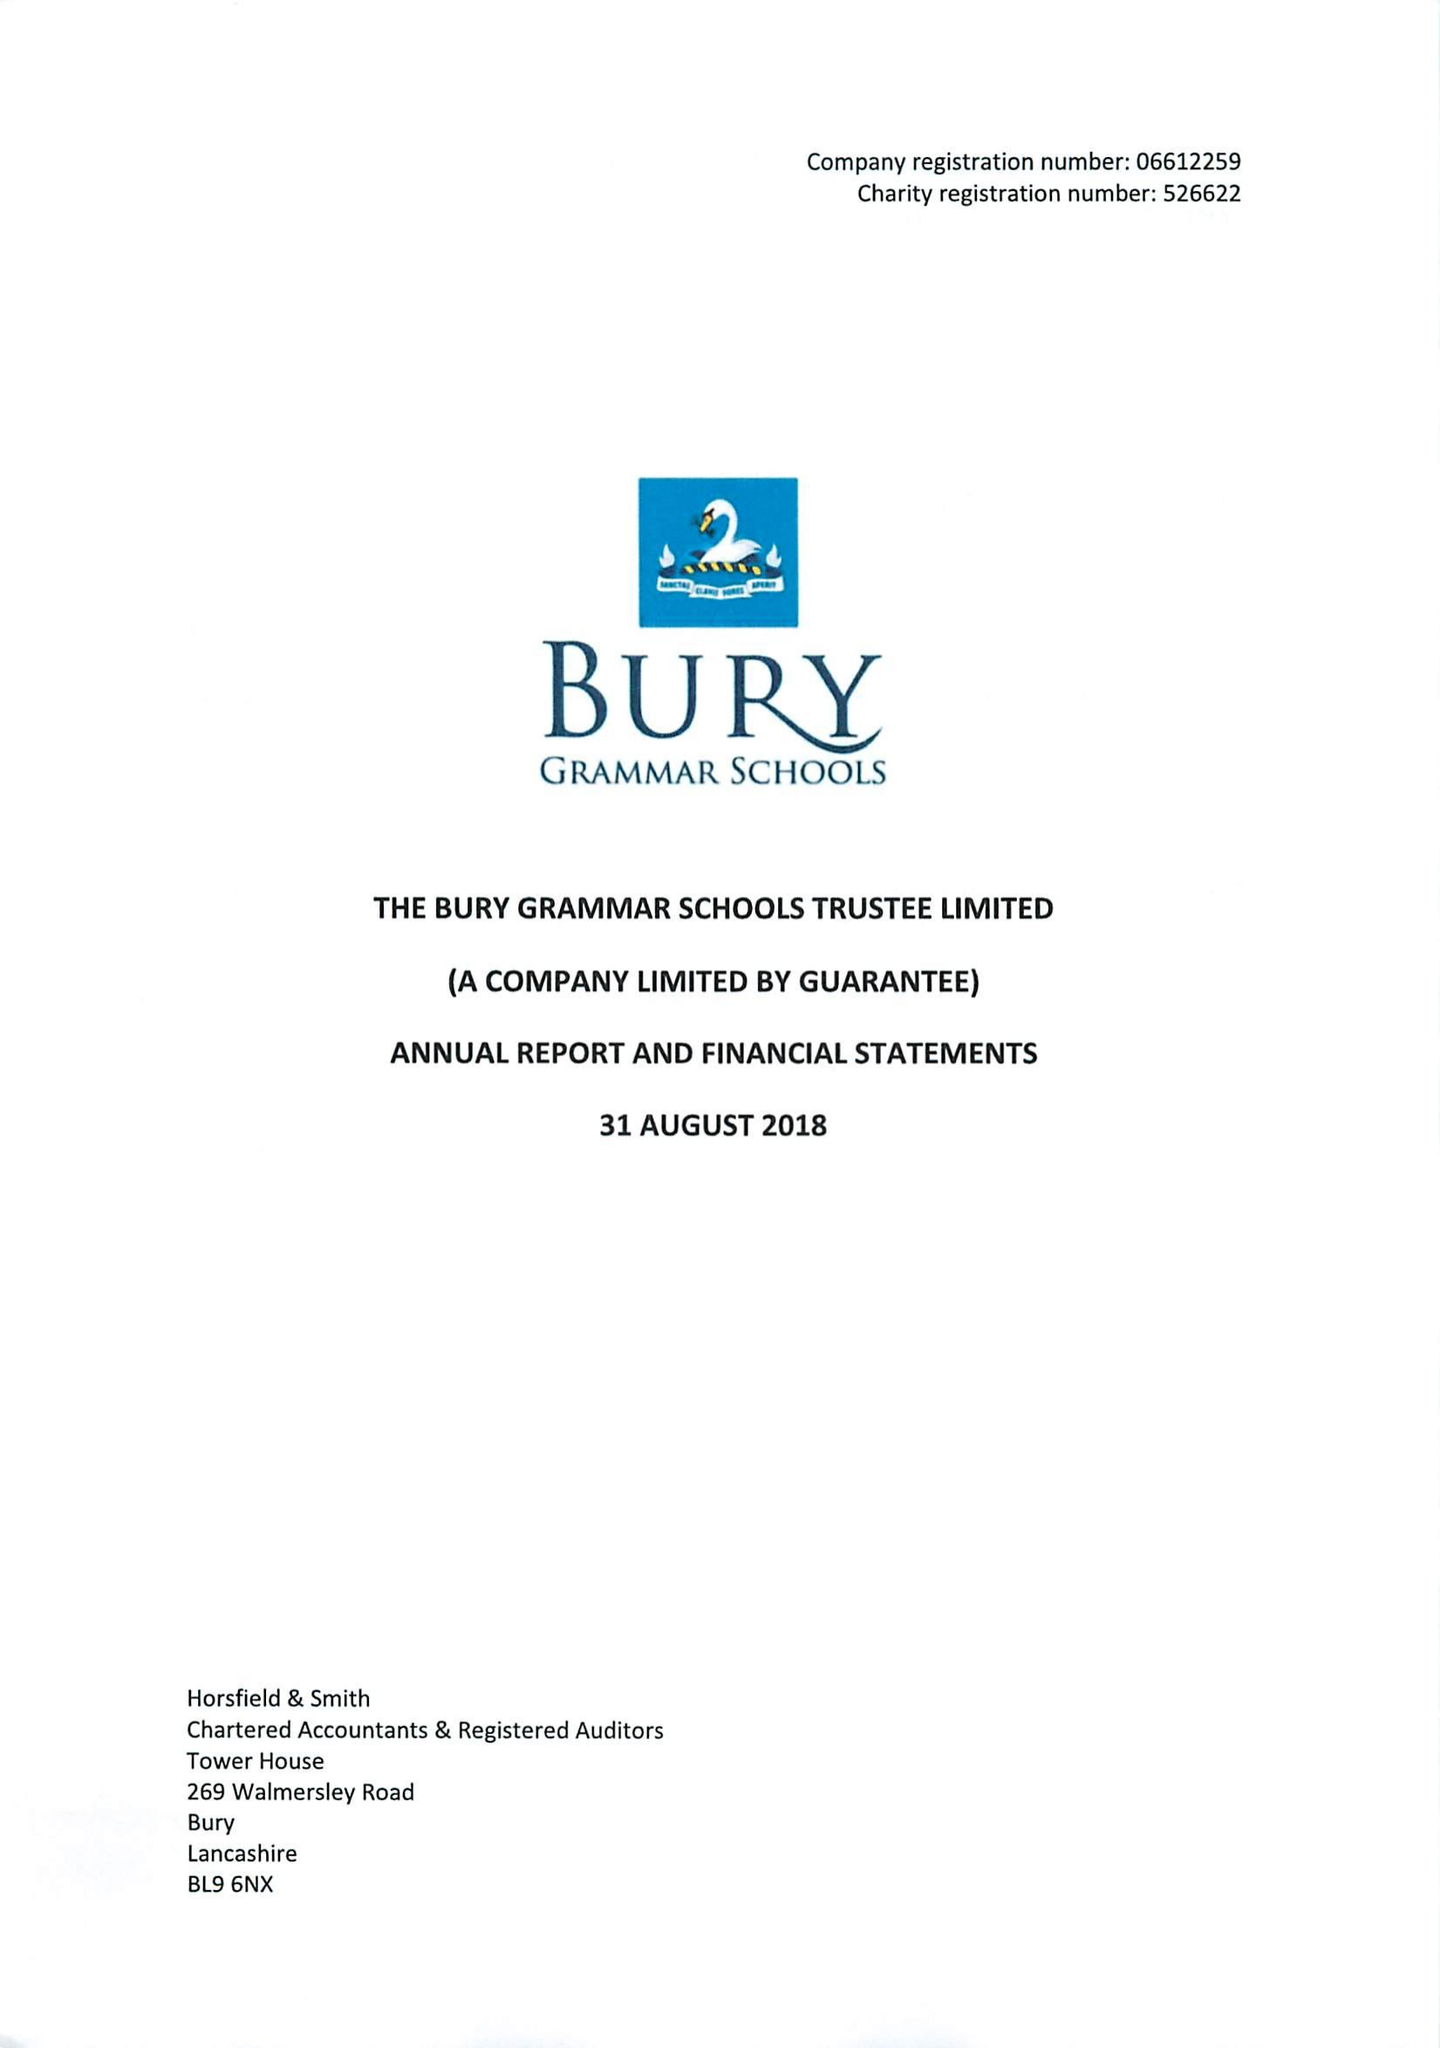What is the value for the report_date?
Answer the question using a single word or phrase. 2018-08-31 